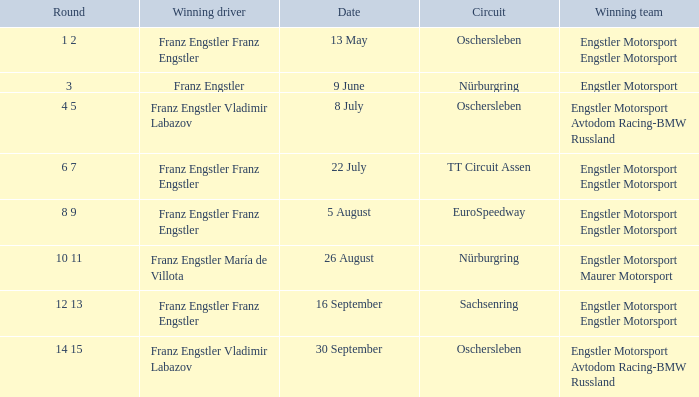Who is the Winning Driver that has a Winning team of Engstler Motorsport Engstler Motorsport and also the Date 22 July? Franz Engstler Franz Engstler. 